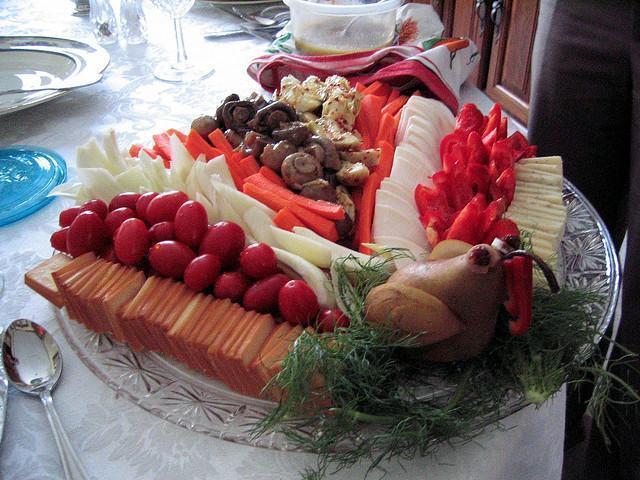What kind of food is between the mushrooms and carrots?
Choose the right answer and clarify with the format: 'Answer: answer
Rationale: rationale.'
Options: Cheese, fruit, vegetable, meat. Answer: vegetable.
Rationale: All of the items on the plate are mostly vegetables. 